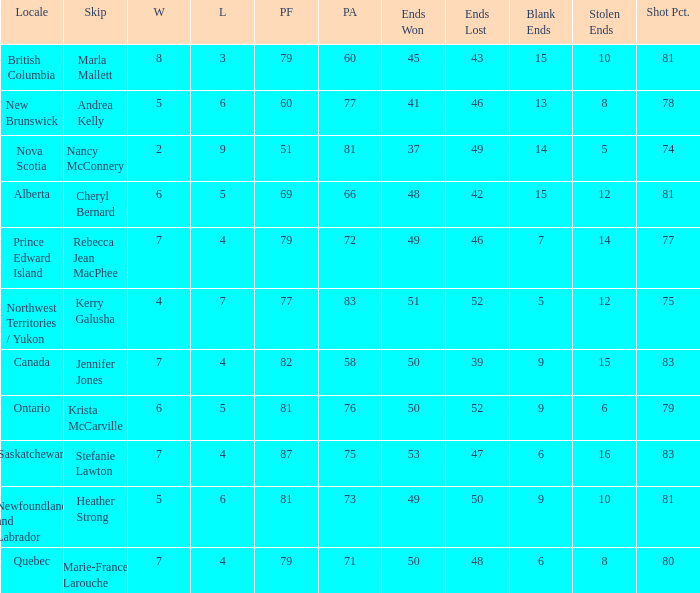What is the pf for Rebecca Jean Macphee? 79.0. 